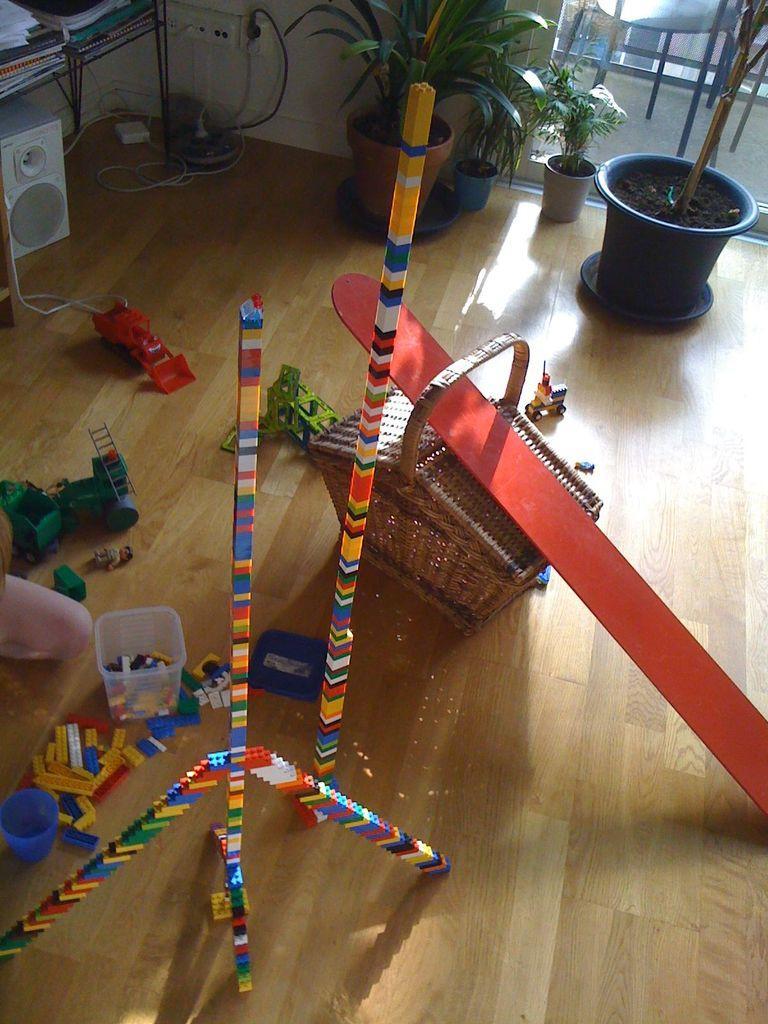Please provide a concise description of this image. In this image, we can see houseplants, some papers and books on the table and there are cables, some toys, a person and we can see a basket, some blocks and there is a container. At the bottom, there is a floor. 